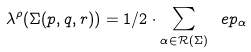Convert formula to latex. <formula><loc_0><loc_0><loc_500><loc_500>\lambda ^ { \rho } ( \Sigma ( p , q , r ) ) = 1 / 2 \cdot \sum _ { \alpha \in { \mathcal { R } } ( \Sigma ) } \ e p _ { \alpha }</formula> 